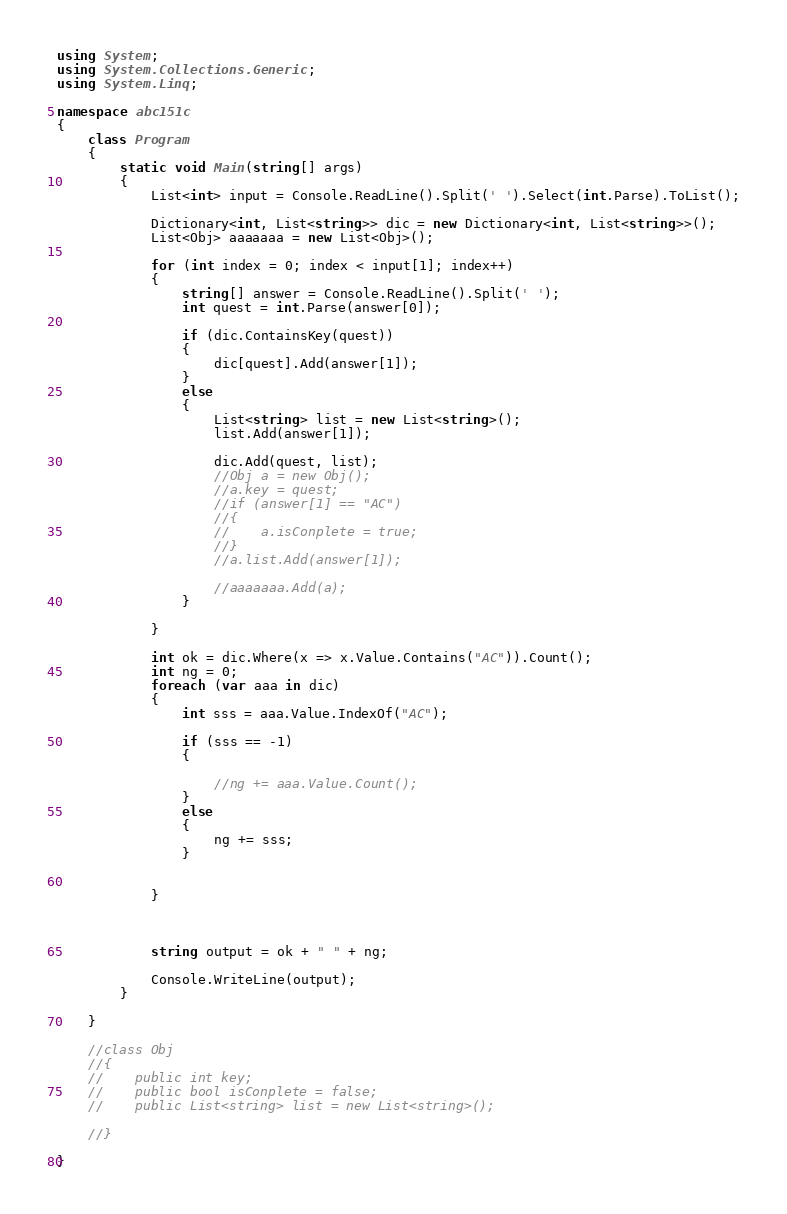Convert code to text. <code><loc_0><loc_0><loc_500><loc_500><_C#_>using System;
using System.Collections.Generic;
using System.Linq;

namespace abc151c
{
    class Program
    {
        static void Main(string[] args)
        {
            List<int> input = Console.ReadLine().Split(' ').Select(int.Parse).ToList();

            Dictionary<int, List<string>> dic = new Dictionary<int, List<string>>();
            List<Obj> aaaaaaa = new List<Obj>();

            for (int index = 0; index < input[1]; index++)
            {
                string[] answer = Console.ReadLine().Split(' ');
                int quest = int.Parse(answer[0]);

                if (dic.ContainsKey(quest))
                {
                    dic[quest].Add(answer[1]);
                }
                else
                {
                    List<string> list = new List<string>();
                    list.Add(answer[1]);

                    dic.Add(quest, list);
                    //Obj a = new Obj();
                    //a.key = quest;
                    //if (answer[1] == "AC")
                    //{
                    //    a.isConplete = true;
                    //}
                    //a.list.Add(answer[1]);

                    //aaaaaaa.Add(a);
                }

            }

            int ok = dic.Where(x => x.Value.Contains("AC")).Count();
            int ng = 0;
            foreach (var aaa in dic)
            {
                int sss = aaa.Value.IndexOf("AC");

                if (sss == -1)
                {

                    //ng += aaa.Value.Count();
                }
                else
                {
                    ng += sss;
                }


            }



            string output = ok + " " + ng;

            Console.WriteLine(output);
        }

    }

    //class Obj
    //{
    //    public int key;
    //    public bool isConplete = false;
    //    public List<string> list = new List<string>();

    //}

}
</code> 